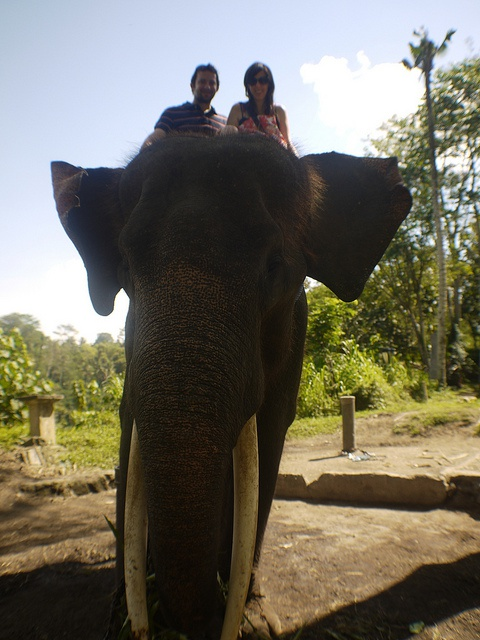Describe the objects in this image and their specific colors. I can see elephant in darkgray, black, olive, and gray tones, people in darkgray, black, gray, maroon, and brown tones, and people in darkgray, black, navy, and gray tones in this image. 